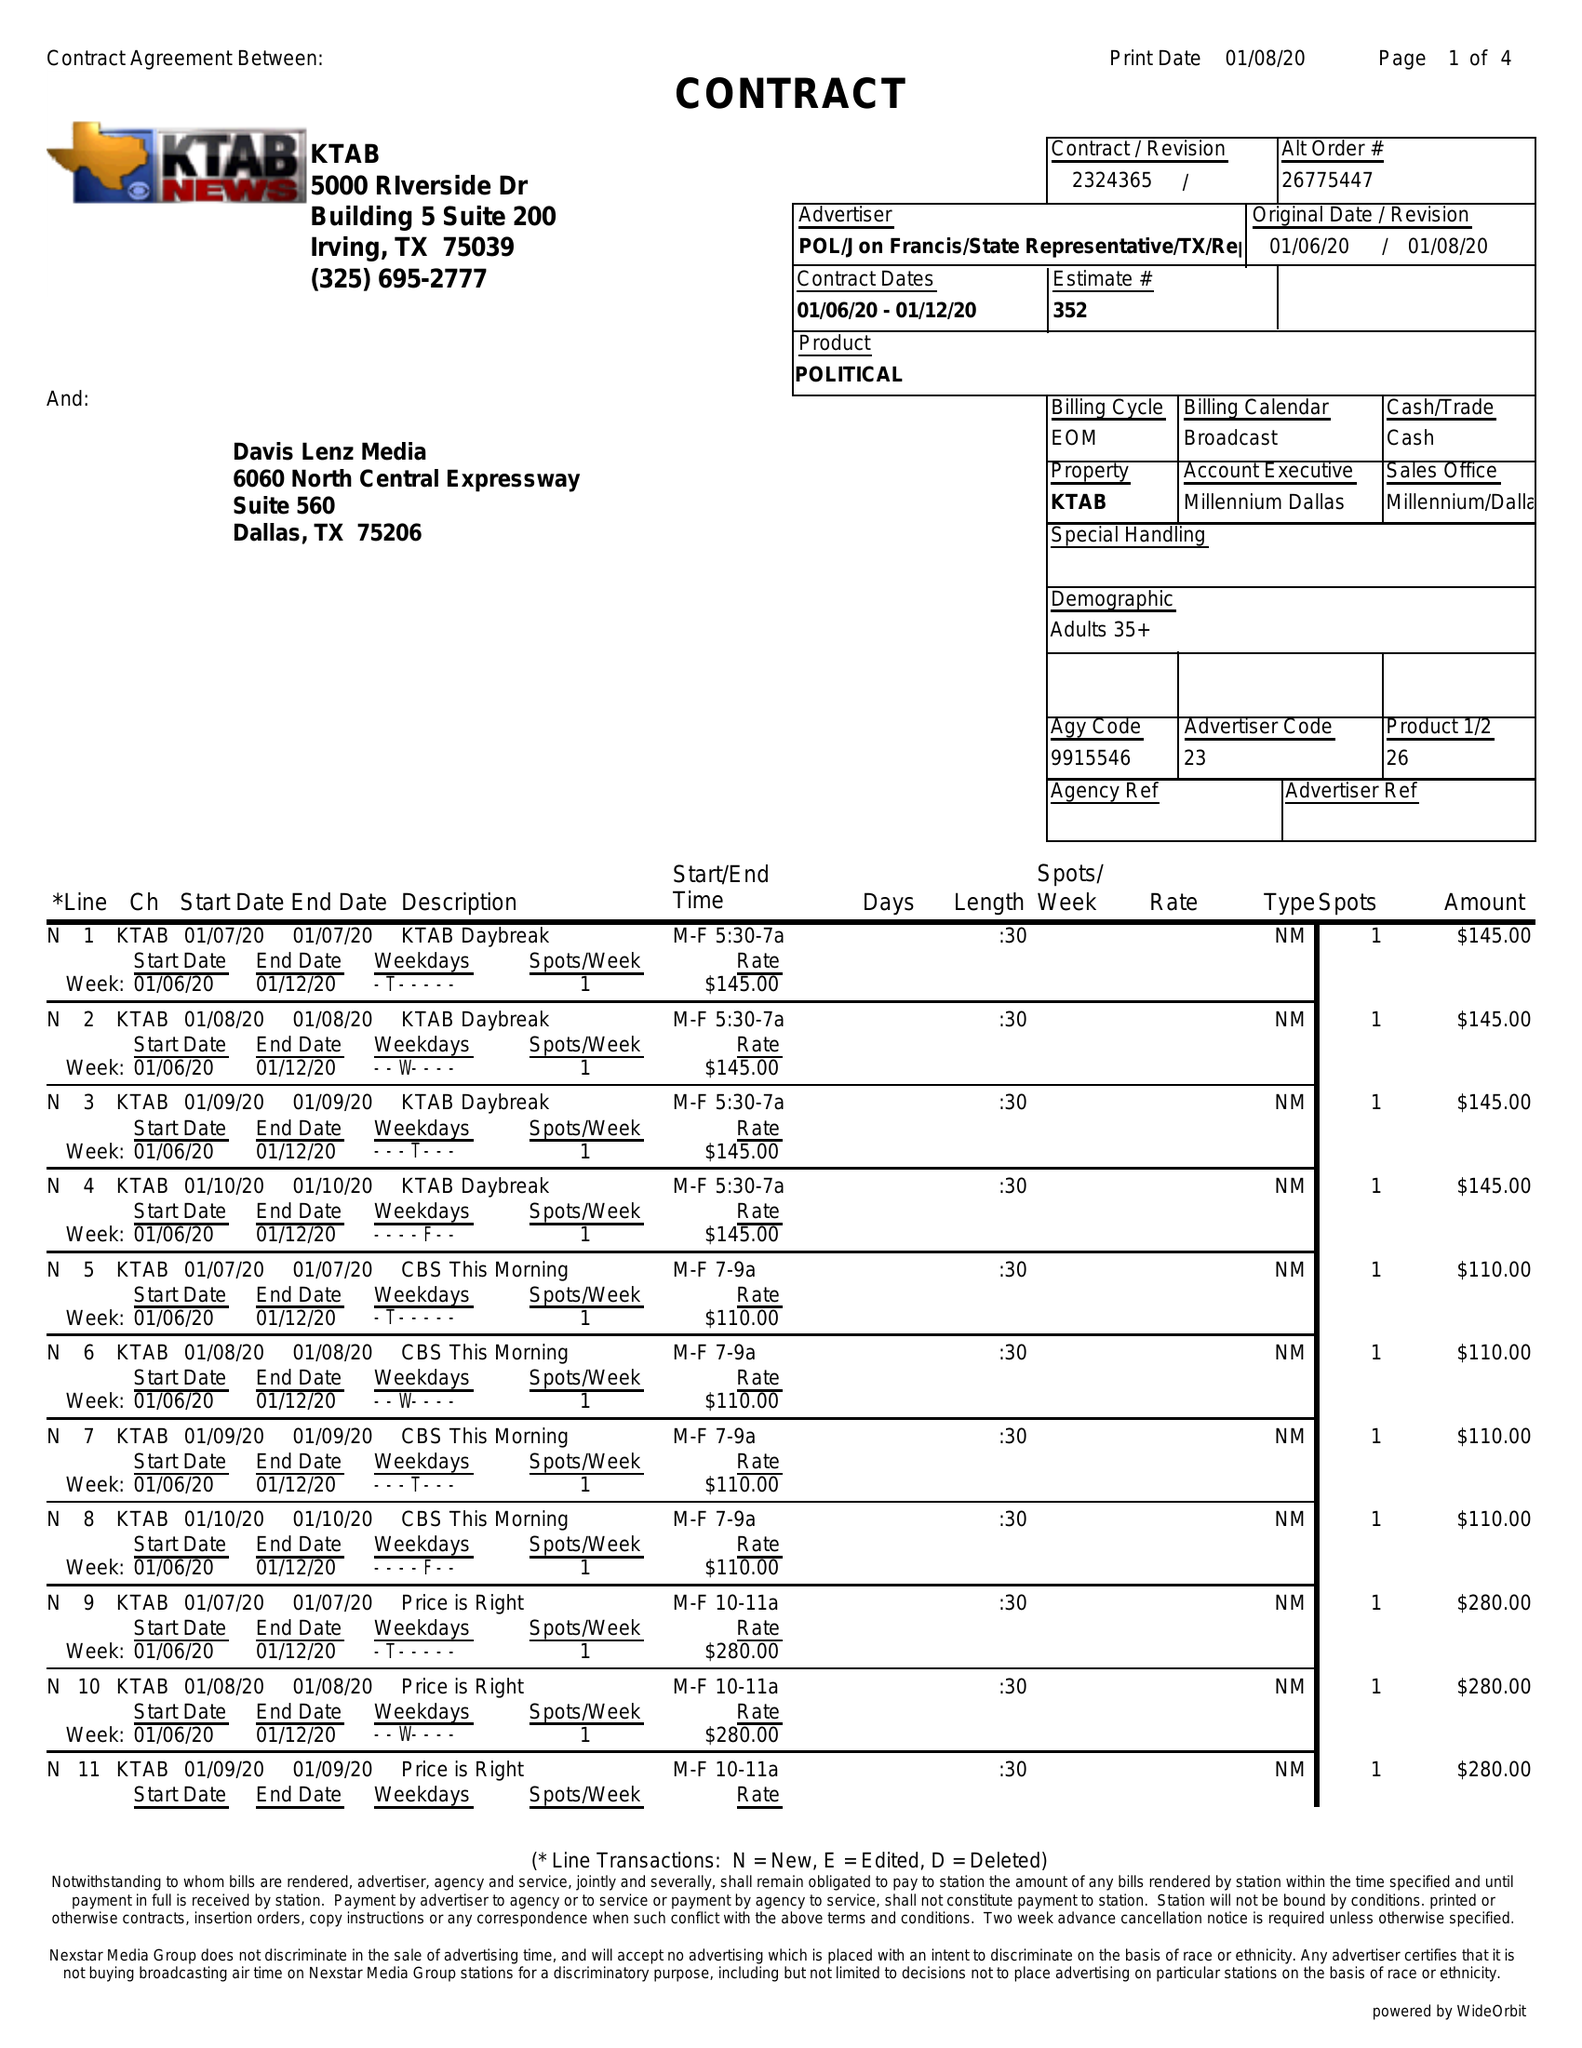What is the value for the advertiser?
Answer the question using a single word or phrase. POL/JONFRANCIS/STATEREPRESENTATIVE/TX/REP 